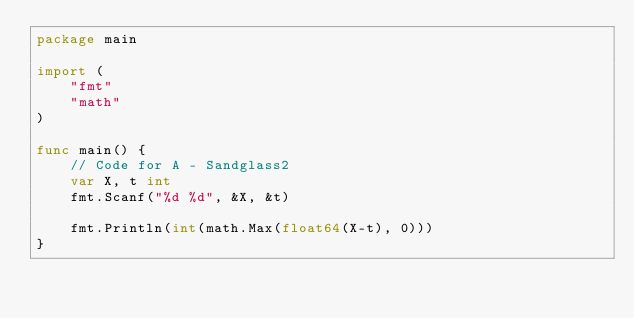Convert code to text. <code><loc_0><loc_0><loc_500><loc_500><_Go_>package main

import (
	"fmt"
	"math"
)

func main() {
	// Code for A - Sandglass2
	var X, t int
	fmt.Scanf("%d %d", &X, &t)

	fmt.Println(int(math.Max(float64(X-t), 0)))
}
</code> 